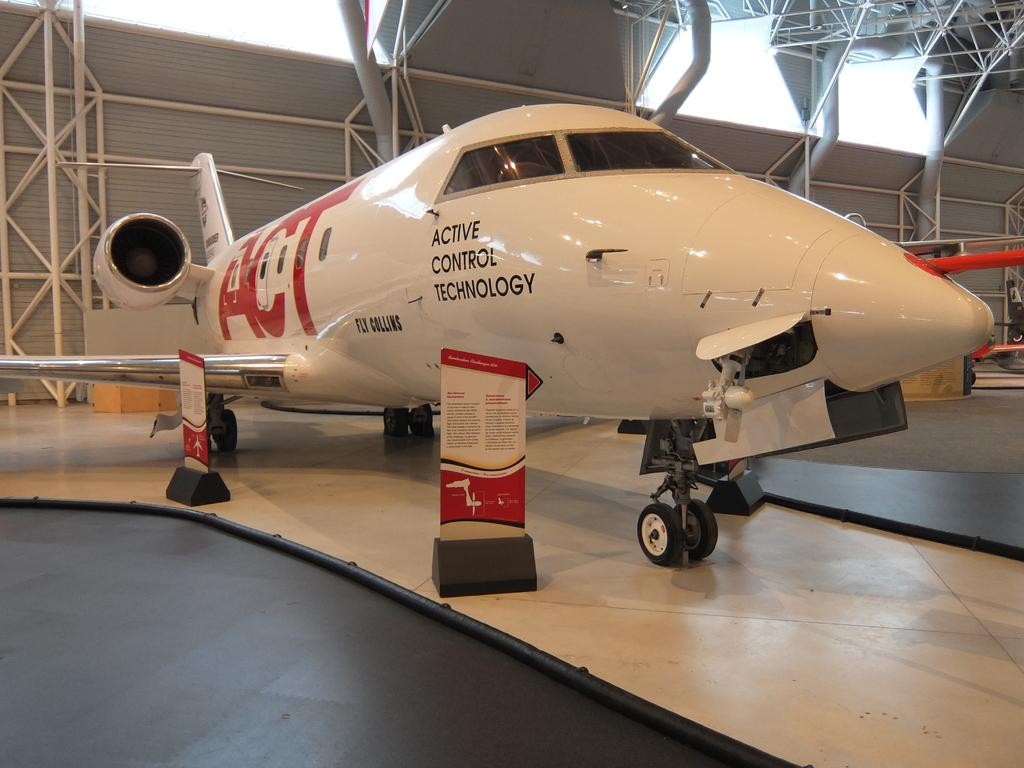<image>
Provide a brief description of the given image. a plane that has the word active on it 